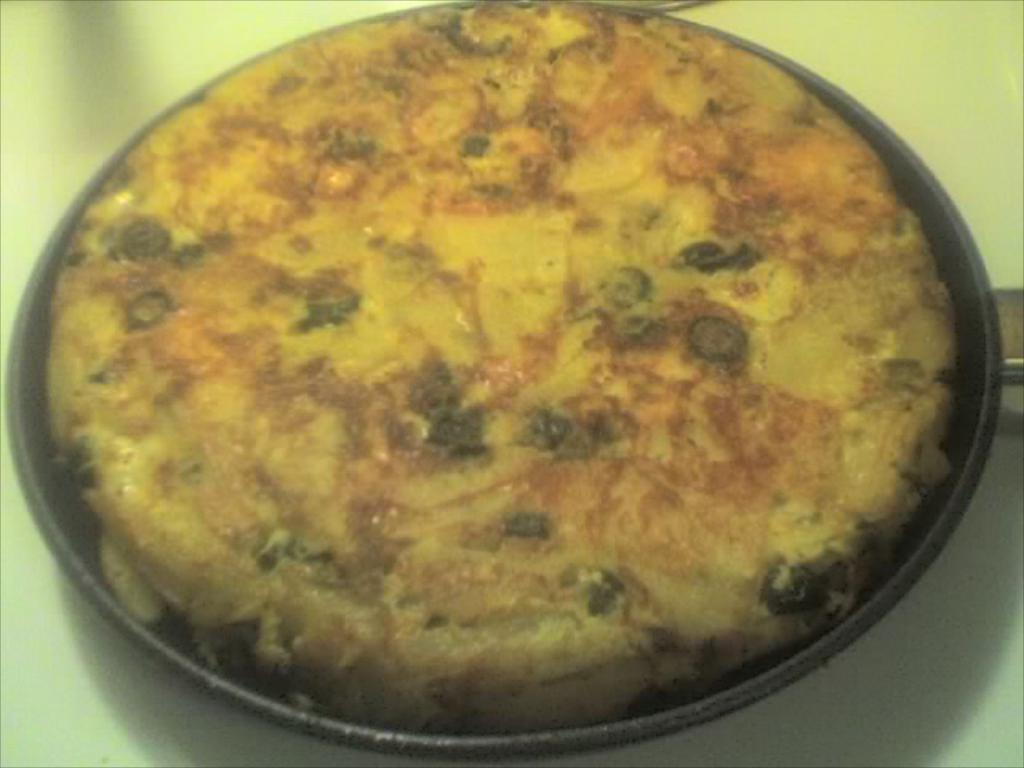What is in the pan that is visible in the image? A: There is food placed in the pan in the image. What is the color of the pan? The pan is black in color. Where is the pan located in the image? The pan is placed on a table. What is the color of the table? The table is white in color. What type of flower is growing in the pan in the image? There is no flower growing in the pan in the image; it contains food. 